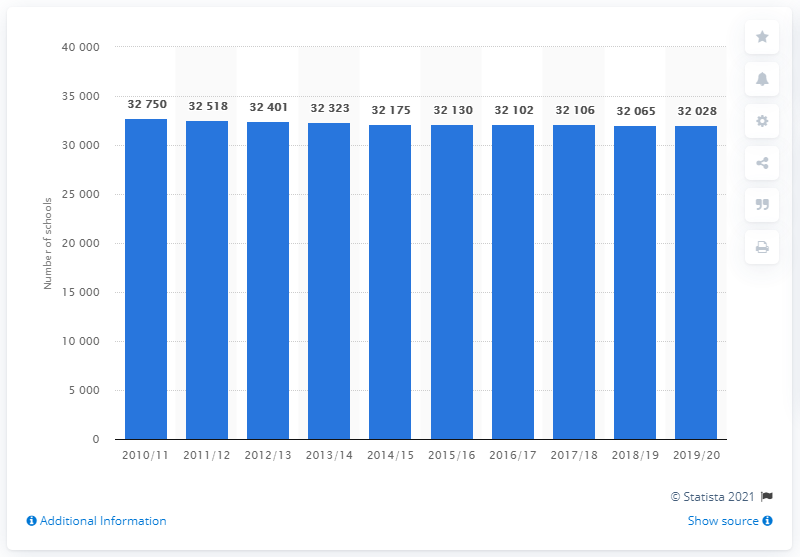Identify some key points in this picture. There were approximately 32,028 schools in the United Kingdom during the academic year 2019/2020. 